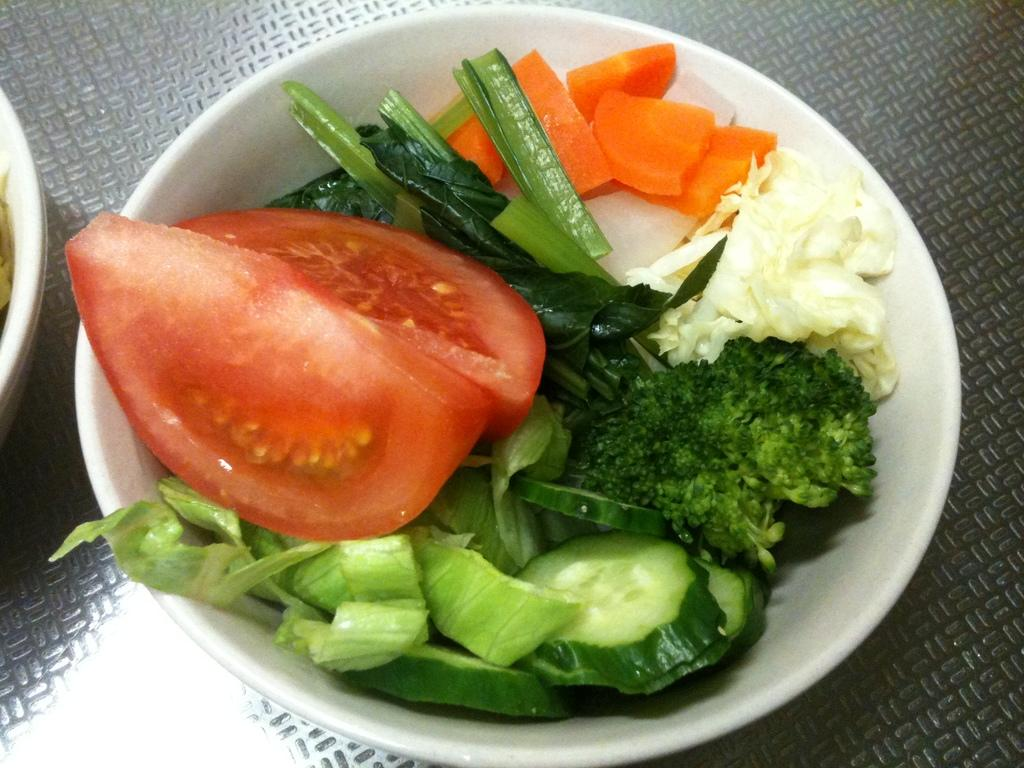What type of food is in the bowl in the image? There are vegetables in a bowl in the image. Can you describe the other bowl in the image? There is another bowl on the left side of the image. How many cats are sitting on the plough in the image? There are no cats or plough present in the image. 